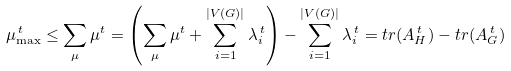Convert formula to latex. <formula><loc_0><loc_0><loc_500><loc_500>\mu _ { \max } ^ { \, t } \leq \sum _ { \mu } \mu ^ { t } = \left ( \sum _ { \mu } \mu ^ { t } + \sum _ { i = 1 } ^ { | V ( G ) | } \lambda _ { i } ^ { \, t } \right ) - \sum _ { i = 1 } ^ { | V ( G ) | } \lambda _ { i } ^ { \, t } = t r ( A _ { H } ^ { \, t } ) - t r ( A _ { G } ^ { \, t } )</formula> 